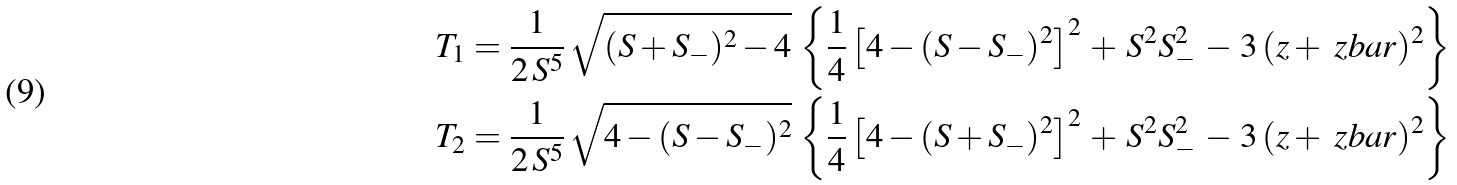Convert formula to latex. <formula><loc_0><loc_0><loc_500><loc_500>T _ { 1 } & = \frac { 1 } { 2 \, S ^ { 5 } } \, \sqrt { ( S + S _ { - } ) ^ { 2 } - 4 } \, \left \{ \frac { 1 } { 4 } \left [ 4 - ( S - S _ { - } ) ^ { 2 } \right ] ^ { 2 } \, + \, S ^ { 2 } S _ { - } ^ { 2 } \, - \, 3 \, ( z + \ z b a r ) ^ { 2 } \right \} \\ T _ { 2 } & = \frac { 1 } { 2 \, S ^ { 5 } } \, \sqrt { 4 - ( S - S _ { - } ) ^ { 2 } } \, \left \{ \frac { 1 } { 4 } \left [ 4 - ( S + S _ { - } ) ^ { 2 } \right ] ^ { 2 } \, + \, S ^ { 2 } S _ { - } ^ { 2 } \, - \, 3 \, ( z + \ z b a r ) ^ { 2 } \right \}</formula> 